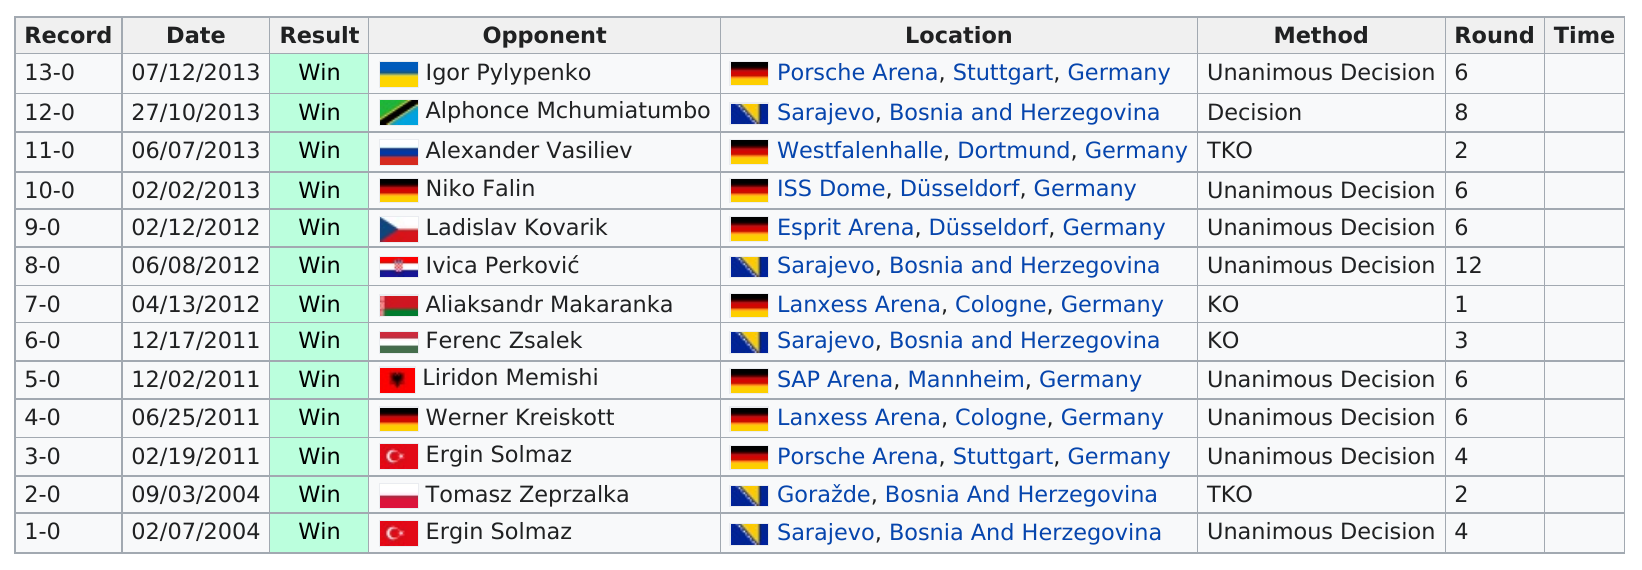Specify some key components in this picture. Adnan Redzovic has a total of 4 knockouts in boxing, including both technical knockouts (TKOs) and regular knockouts. The method listed the least is Decision. The name of the last opponent on this chart is Ergin Solmaz. According to the chart provided, the location that is listed the most is Sarajevo, Bosnia and Herzegovina. In the second match, there were more rounds compared to the third match. 